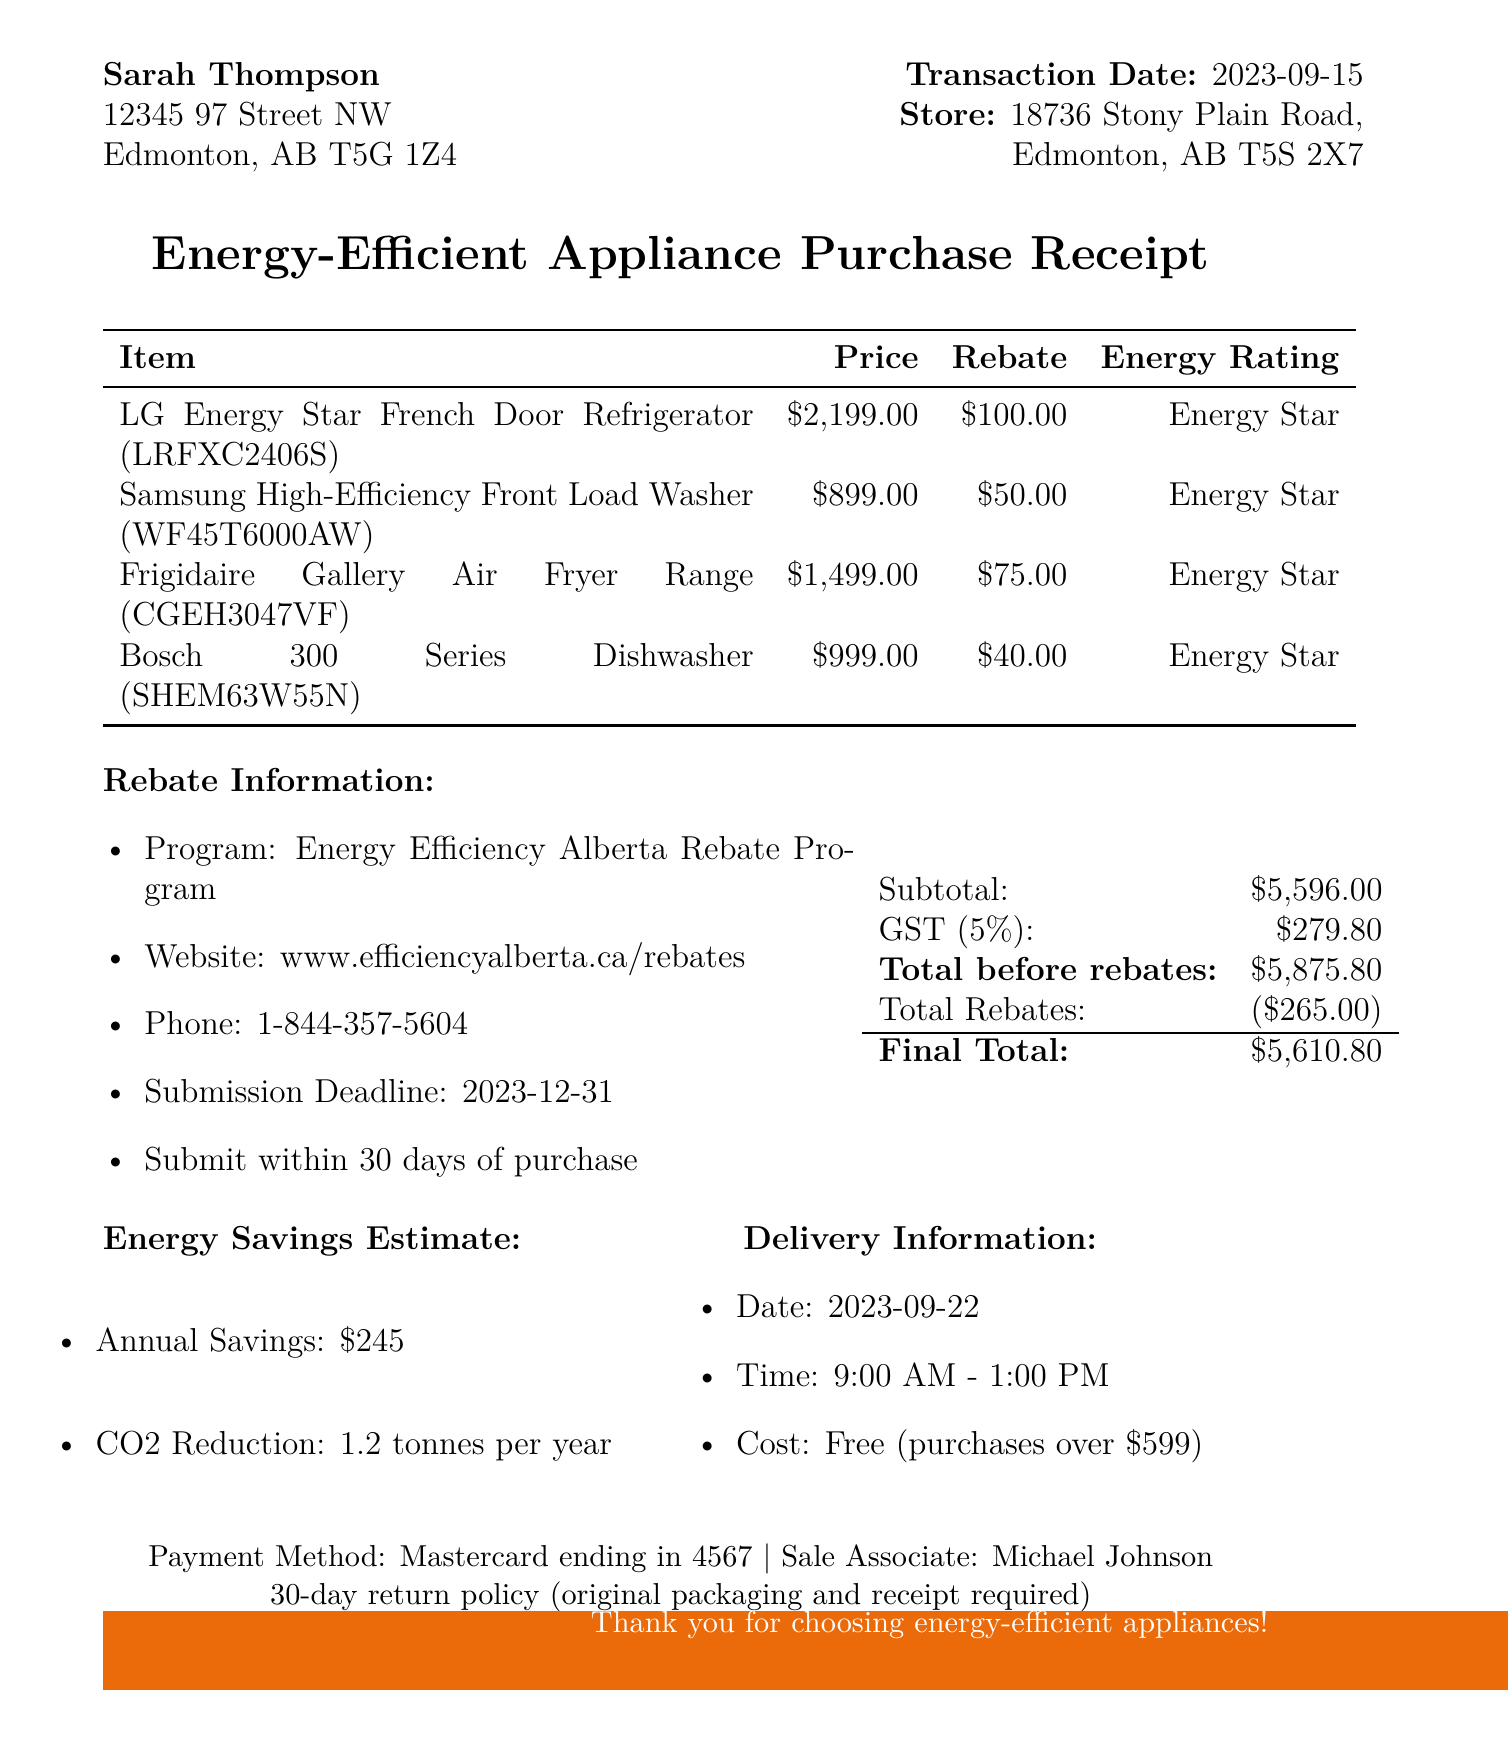What is the store name? The store name is listed at the top of the receipt.
Answer: The Home Depot What is the transaction date? The transaction date is specified under the store information section.
Answer: 2023-09-15 What is the total before rebates? The total before rebates is provided in the summary section of the document.
Answer: 5,875.80 What is the rebate amount for the LG refrigerator? Each item lists its corresponding rebate amount.
Answer: 100.00 What is the annual energy savings estimate? The energy savings estimate is detailed in the energy savings section.
Answer: $245 How many days do you have to submit the rebate application? The rebate information specifies the number of days allowed for application submission.
Answer: 30 days What is the delivery date for the appliances? The delivery date is included in the delivery information section.
Answer: 2023-09-22 What is the return policy duration? The return policy details are mentioned in the latter part of the document.
Answer: 30-day return policy Which sale event is mentioned in the document? The name of the seasonal sale is stated prominently at the top of the receipt.
Answer: Fall Energy Savings Event 